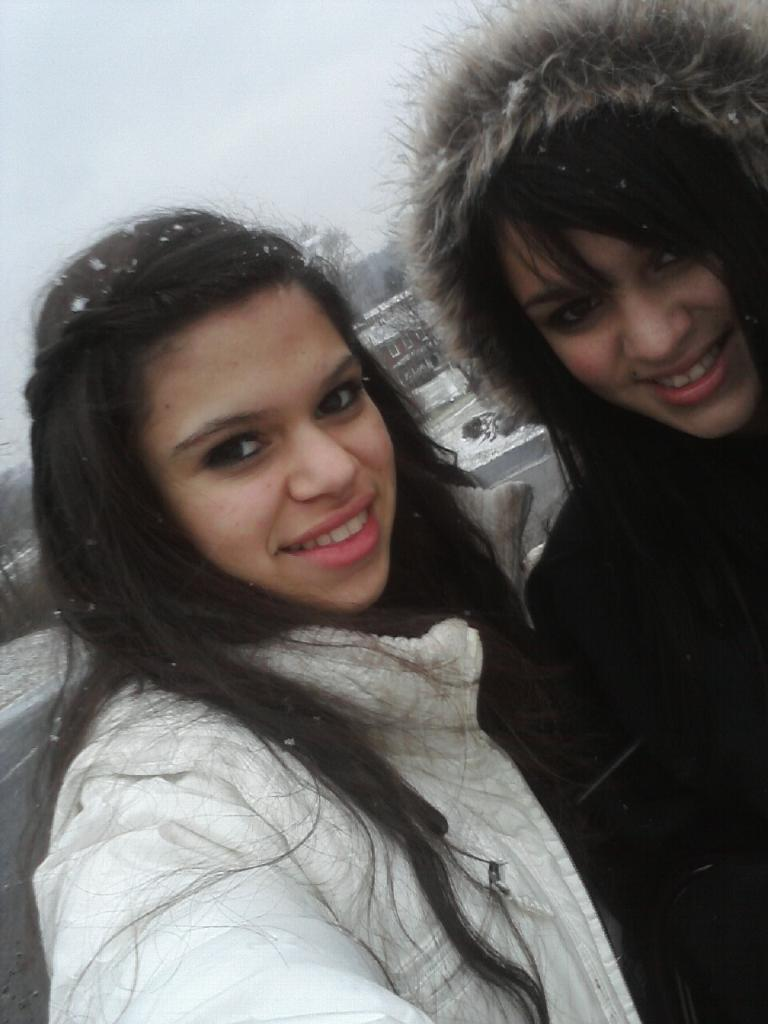How many people are in the image? There are two women in the image. What are the women doing in the image? The women are taking a selfie. Can you describe the weather or temperature based on the image? The climate is cool. What is located behind the women in the image? There is a house behind the women. What can be seen in the background of the image? The sky is visible in the background. What type of pleasure can be seen in the image? The image does not depict any specific pleasure or activity related to pleasure. 